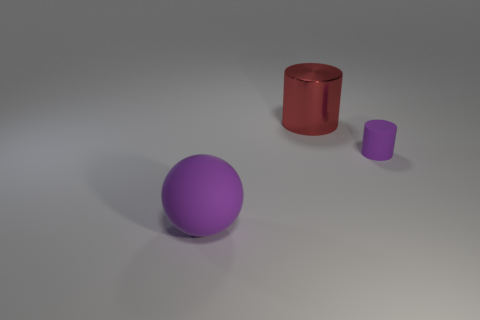Add 3 blue cylinders. How many objects exist? 6 Subtract all spheres. How many objects are left? 2 Subtract all purple rubber things. Subtract all tiny cyan cubes. How many objects are left? 1 Add 2 purple things. How many purple things are left? 4 Add 3 big metallic things. How many big metallic things exist? 4 Subtract 0 yellow blocks. How many objects are left? 3 